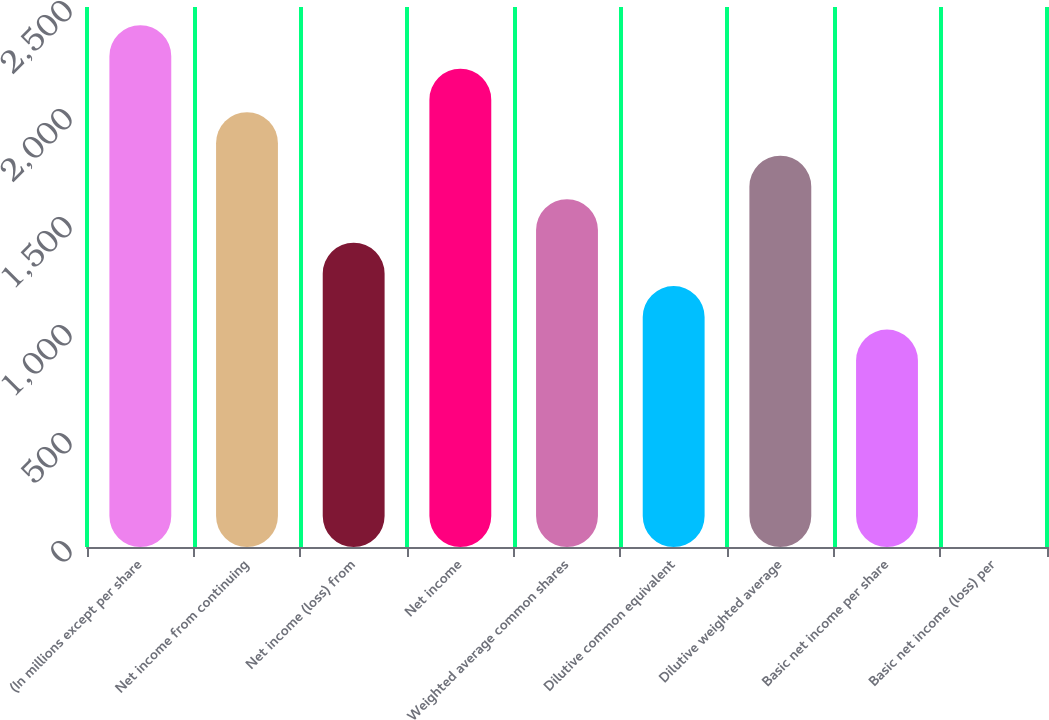Convert chart to OTSL. <chart><loc_0><loc_0><loc_500><loc_500><bar_chart><fcel>(In millions except per share<fcel>Net income from continuing<fcel>Net income (loss) from<fcel>Net income<fcel>Weighted average common shares<fcel>Dilutive common equivalent<fcel>Dilutive weighted average<fcel>Basic net income per share<fcel>Basic net income (loss) per<nl><fcel>2415.53<fcel>2012.97<fcel>1409.13<fcel>2214.25<fcel>1610.41<fcel>1207.85<fcel>1811.69<fcel>1006.57<fcel>0.17<nl></chart> 